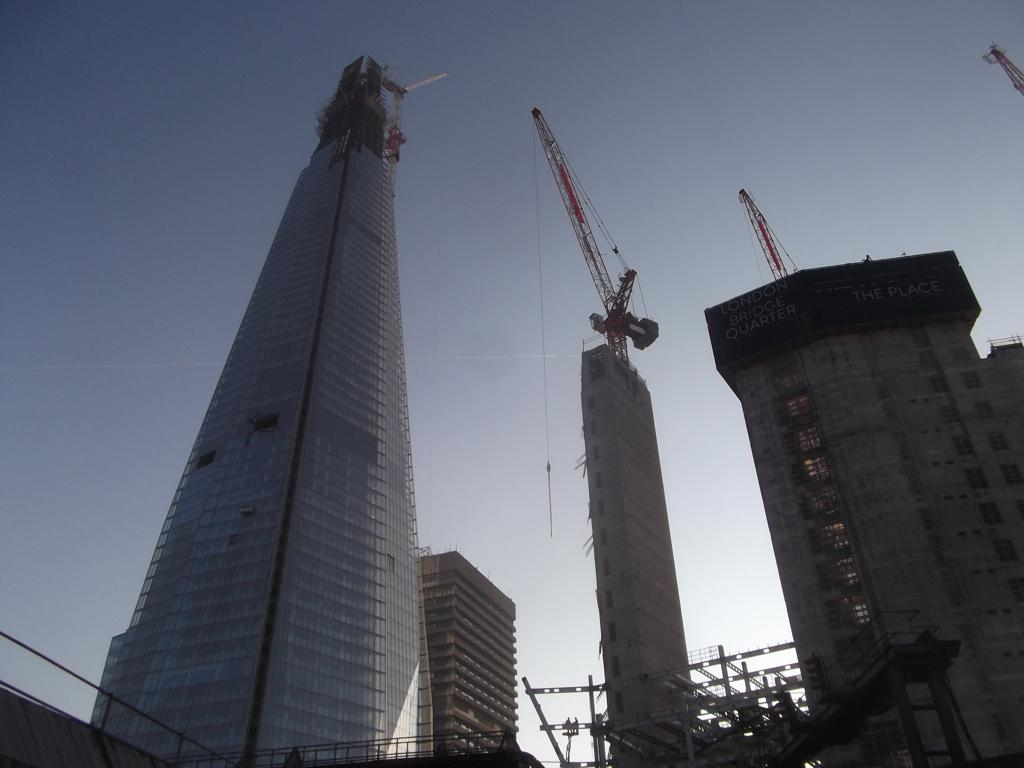What type of structures can be seen in the image? There are buildings in the image. What construction equipment is present in the image? There are cranes in the image. What type of material is visible in the image? There are metal rods in the image. What can be seen in the background of the image? The sky is visible in the background of the image. How does the spy communicate with their team in the image? There is no spy present in the image, so it is not possible to determine how they would communicate. 